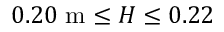<formula> <loc_0><loc_0><loc_500><loc_500>0 . 2 0 m \leq H \leq 0 . 2 2</formula> 